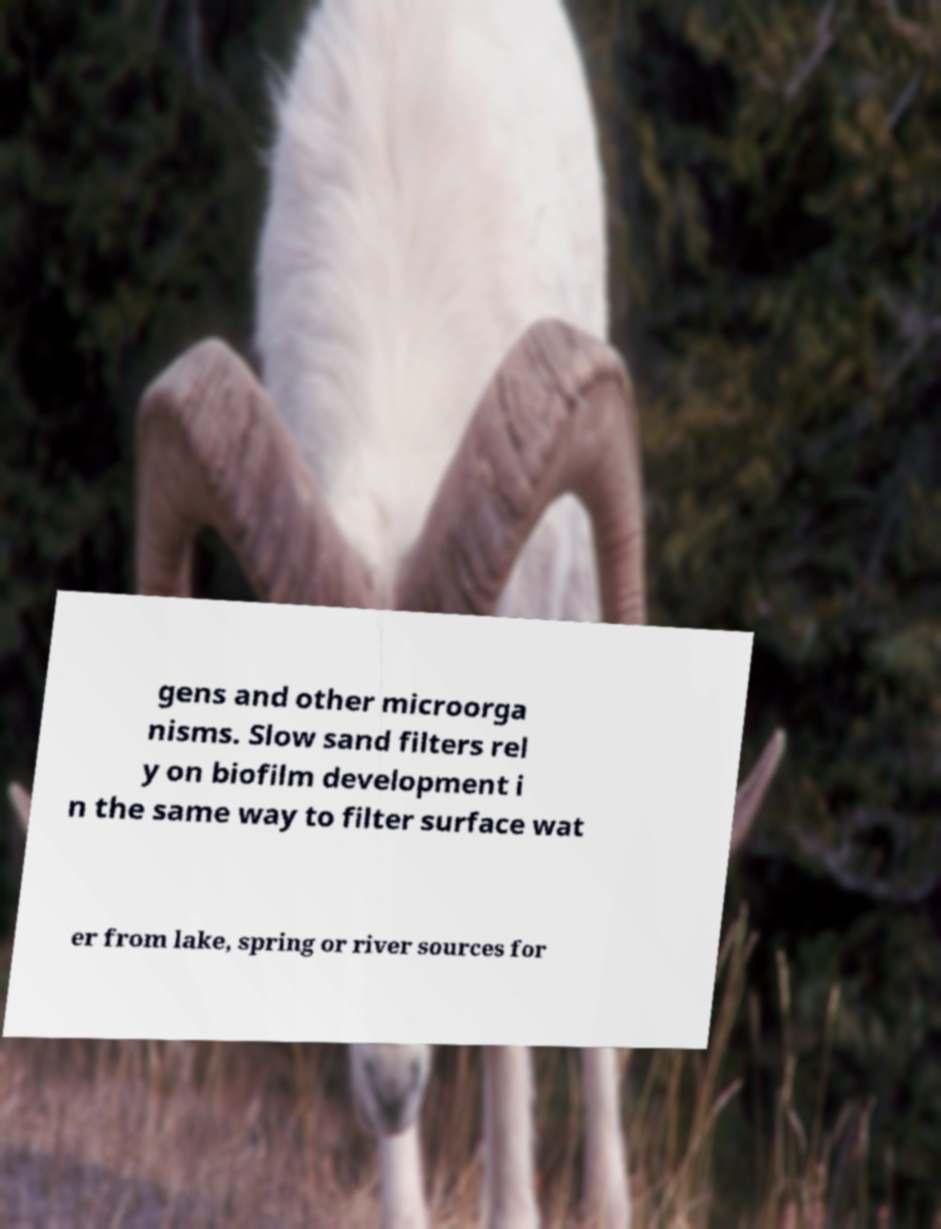Please read and relay the text visible in this image. What does it say? gens and other microorga nisms. Slow sand filters rel y on biofilm development i n the same way to filter surface wat er from lake, spring or river sources for 